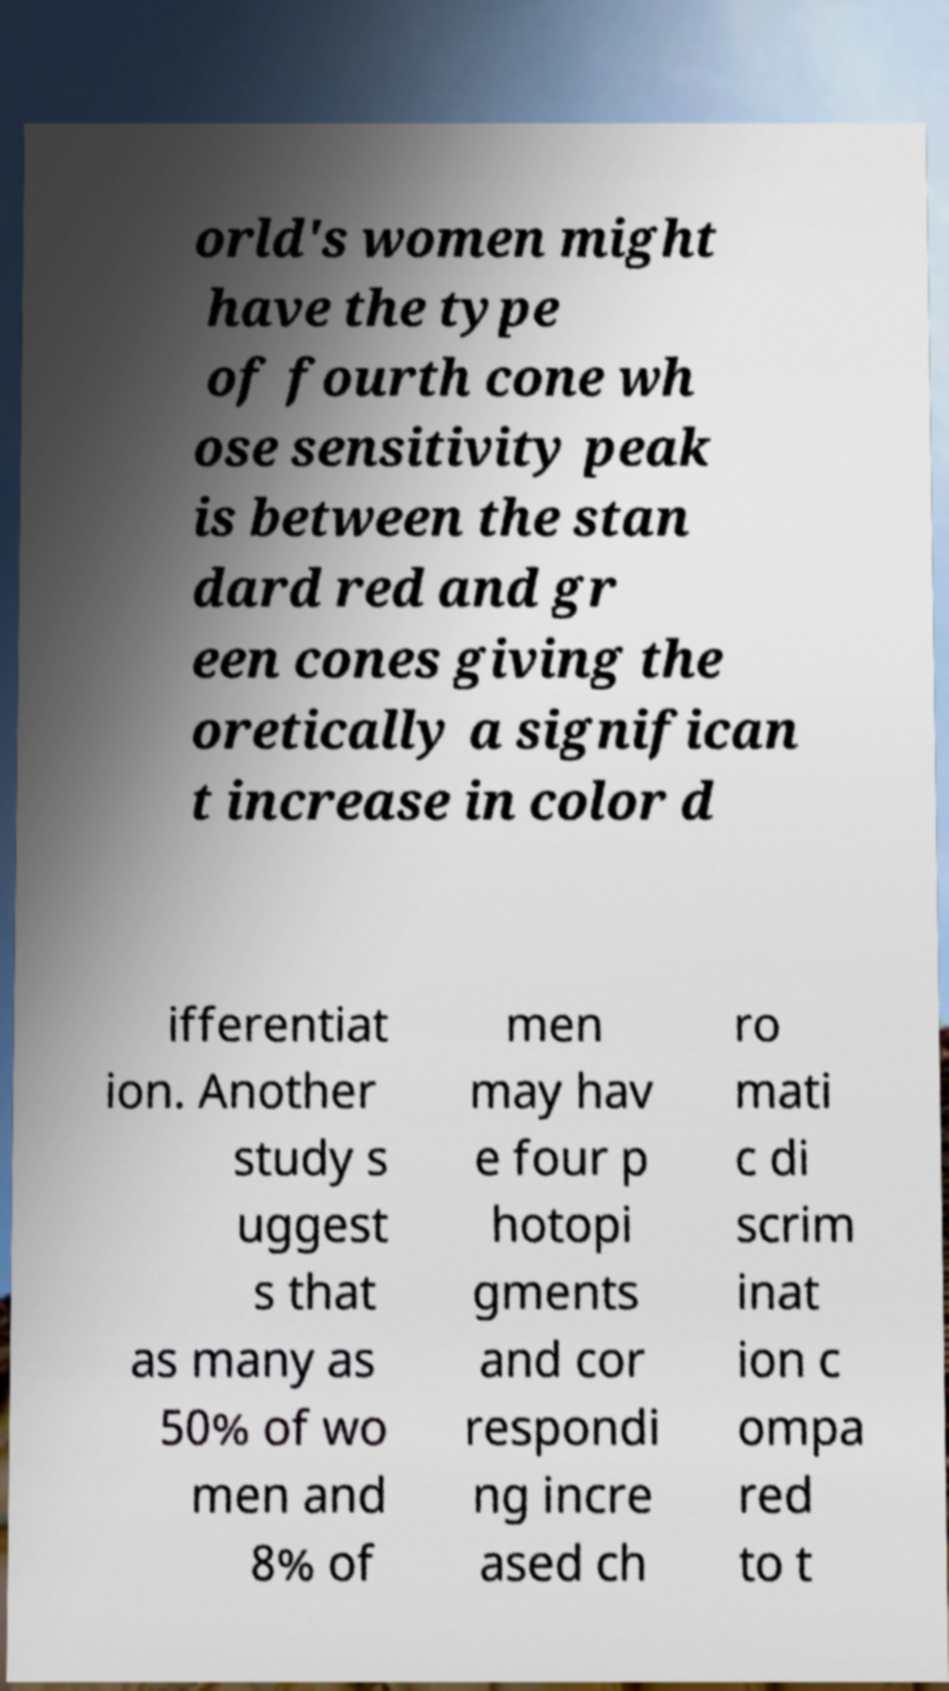For documentation purposes, I need the text within this image transcribed. Could you provide that? orld's women might have the type of fourth cone wh ose sensitivity peak is between the stan dard red and gr een cones giving the oretically a significan t increase in color d ifferentiat ion. Another study s uggest s that as many as 50% of wo men and 8% of men may hav e four p hotopi gments and cor respondi ng incre ased ch ro mati c di scrim inat ion c ompa red to t 